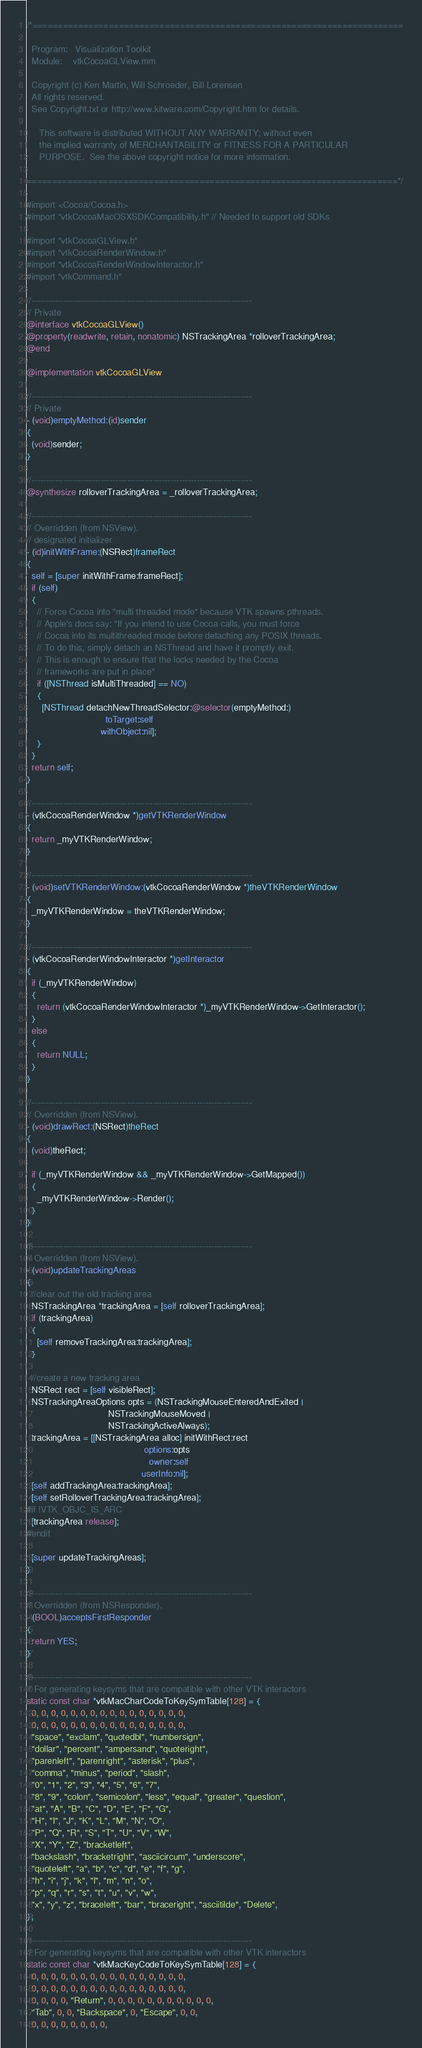Convert code to text. <code><loc_0><loc_0><loc_500><loc_500><_ObjectiveC_>/*=========================================================================

  Program:   Visualization Toolkit
  Module:    vtkCocoaGLView.mm

  Copyright (c) Ken Martin, Will Schroeder, Bill Lorensen
  All rights reserved.
  See Copyright.txt or http://www.kitware.com/Copyright.htm for details.

     This software is distributed WITHOUT ANY WARRANTY; without even
     the implied warranty of MERCHANTABILITY or FITNESS FOR A PARTICULAR
     PURPOSE.  See the above copyright notice for more information.

=========================================================================*/

#import <Cocoa/Cocoa.h>
#import "vtkCocoaMacOSXSDKCompatibility.h" // Needed to support old SDKs

#import "vtkCocoaGLView.h"
#import "vtkCocoaRenderWindow.h"
#import "vtkCocoaRenderWindowInteractor.h"
#import "vtkCommand.h"

//----------------------------------------------------------------------------
// Private
@interface vtkCocoaGLView()
@property(readwrite, retain, nonatomic) NSTrackingArea *rolloverTrackingArea;
@end

@implementation vtkCocoaGLView

//----------------------------------------------------------------------------
// Private
- (void)emptyMethod:(id)sender
{
  (void)sender;
}

//----------------------------------------------------------------------------
@synthesize rolloverTrackingArea = _rolloverTrackingArea;

//----------------------------------------------------------------------------
// Overridden (from NSView).
// designated initializer
- (id)initWithFrame:(NSRect)frameRect
{
  self = [super initWithFrame:frameRect];
  if (self)
  {
    // Force Cocoa into "multi threaded mode" because VTK spawns pthreads.
    // Apple's docs say: "If you intend to use Cocoa calls, you must force
    // Cocoa into its multithreaded mode before detaching any POSIX threads.
    // To do this, simply detach an NSThread and have it promptly exit.
    // This is enough to ensure that the locks needed by the Cocoa
    // frameworks are put in place"
    if ([NSThread isMultiThreaded] == NO)
    {
      [NSThread detachNewThreadSelector:@selector(emptyMethod:)
                               toTarget:self
                             withObject:nil];
    }
  }
  return self;
}

//----------------------------------------------------------------------------
- (vtkCocoaRenderWindow *)getVTKRenderWindow
{
  return _myVTKRenderWindow;
}

//----------------------------------------------------------------------------
- (void)setVTKRenderWindow:(vtkCocoaRenderWindow *)theVTKRenderWindow
{
  _myVTKRenderWindow = theVTKRenderWindow;
}

//----------------------------------------------------------------------------
- (vtkCocoaRenderWindowInteractor *)getInteractor
{
  if (_myVTKRenderWindow)
  {
    return (vtkCocoaRenderWindowInteractor *)_myVTKRenderWindow->GetInteractor();
  }
  else
  {
    return NULL;
  }
}

//----------------------------------------------------------------------------
// Overridden (from NSView).
- (void)drawRect:(NSRect)theRect
{
  (void)theRect;

  if (_myVTKRenderWindow && _myVTKRenderWindow->GetMapped())
  {
    _myVTKRenderWindow->Render();
  }
}

//----------------------------------------------------------------------------
// Overridden (from NSView).
- (void)updateTrackingAreas
{
  //clear out the old tracking area
  NSTrackingArea *trackingArea = [self rolloverTrackingArea];
  if (trackingArea)
  {
    [self removeTrackingArea:trackingArea];
  }

  //create a new tracking area
  NSRect rect = [self visibleRect];
  NSTrackingAreaOptions opts = (NSTrackingMouseEnteredAndExited |
                                NSTrackingMouseMoved |
                                NSTrackingActiveAlways);
  trackingArea = [[NSTrackingArea alloc] initWithRect:rect
                                              options:opts
                                                owner:self
                                             userInfo:nil];
  [self addTrackingArea:trackingArea];
  [self setRolloverTrackingArea:trackingArea];
#if !VTK_OBJC_IS_ARC
  [trackingArea release];
#endif

  [super updateTrackingAreas];
}

//----------------------------------------------------------------------------
// Overridden (from NSResponder).
- (BOOL)acceptsFirstResponder
{
  return YES;
}

//----------------------------------------------------------------------------
// For generating keysyms that are compatible with other VTK interactors
static const char *vtkMacCharCodeToKeySymTable[128] = {
  0, 0, 0, 0, 0, 0, 0, 0, 0, 0, 0, 0, 0, 0, 0, 0,
  0, 0, 0, 0, 0, 0, 0, 0, 0, 0, 0, 0, 0, 0, 0, 0,
  "space", "exclam", "quotedbl", "numbersign",
  "dollar", "percent", "ampersand", "quoteright",
  "parenleft", "parenright", "asterisk", "plus",
  "comma", "minus", "period", "slash",
  "0", "1", "2", "3", "4", "5", "6", "7",
  "8", "9", "colon", "semicolon", "less", "equal", "greater", "question",
  "at", "A", "B", "C", "D", "E", "F", "G",
  "H", "I", "J", "K", "L", "M", "N", "O",
  "P", "Q", "R", "S", "T", "U", "V", "W",
  "X", "Y", "Z", "bracketleft",
  "backslash", "bracketright", "asciicircum", "underscore",
  "quoteleft", "a", "b", "c", "d", "e", "f", "g",
  "h", "i", "j", "k", "l", "m", "n", "o",
  "p", "q", "r", "s", "t", "u", "v", "w",
  "x", "y", "z", "braceleft", "bar", "braceright", "asciitilde", "Delete",
};

//----------------------------------------------------------------------------
// For generating keysyms that are compatible with other VTK interactors
static const char *vtkMacKeyCodeToKeySymTable[128] = {
  0, 0, 0, 0, 0, 0, 0, 0, 0, 0, 0, 0, 0, 0, 0, 0,
  0, 0, 0, 0, 0, 0, 0, 0, 0, 0, 0, 0, 0, 0, 0, 0,
  0, 0, 0, 0, "Return", 0, 0, 0, 0, 0, 0, 0, 0, 0, 0, 0,
  "Tab", 0, 0, "Backspace", 0, "Escape", 0, 0,
  0, 0, 0, 0, 0, 0, 0, 0,</code> 